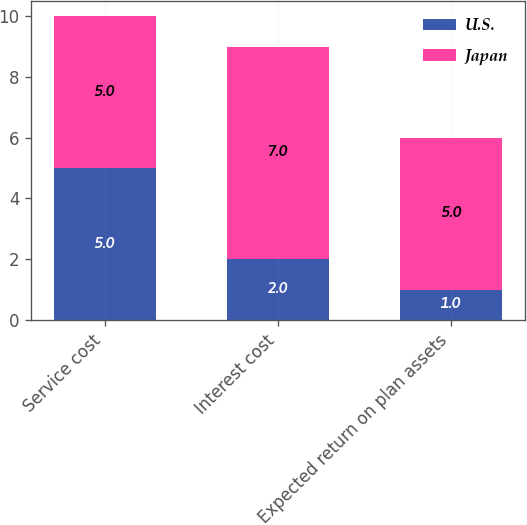Convert chart. <chart><loc_0><loc_0><loc_500><loc_500><stacked_bar_chart><ecel><fcel>Service cost<fcel>Interest cost<fcel>Expected return on plan assets<nl><fcel>U.S.<fcel>5<fcel>2<fcel>1<nl><fcel>Japan<fcel>5<fcel>7<fcel>5<nl></chart> 